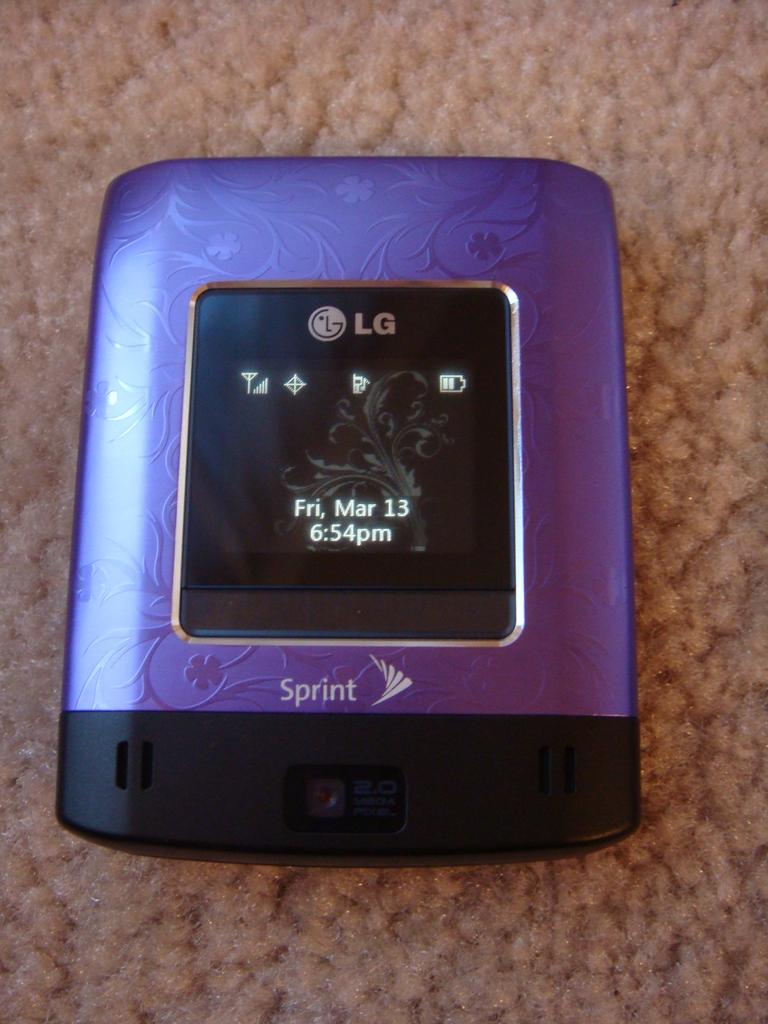What time does the clock read?
Provide a short and direct response. 6:54. Who is the phone carrier?
Make the answer very short. Sprint. 